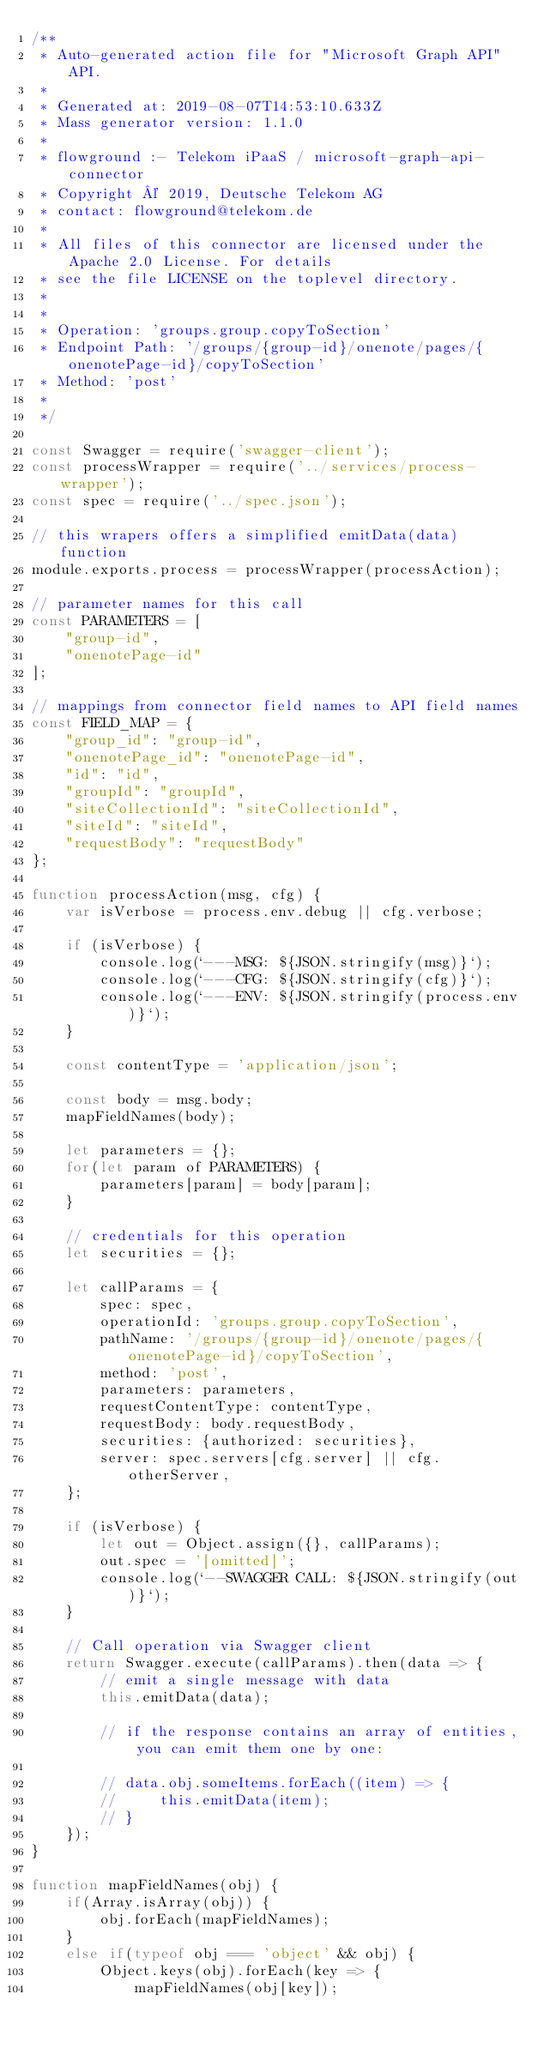Convert code to text. <code><loc_0><loc_0><loc_500><loc_500><_JavaScript_>/**
 * Auto-generated action file for "Microsoft Graph API" API.
 *
 * Generated at: 2019-08-07T14:53:10.633Z
 * Mass generator version: 1.1.0
 *
 * flowground :- Telekom iPaaS / microsoft-graph-api-connector
 * Copyright © 2019, Deutsche Telekom AG
 * contact: flowground@telekom.de
 *
 * All files of this connector are licensed under the Apache 2.0 License. For details
 * see the file LICENSE on the toplevel directory.
 *
 *
 * Operation: 'groups.group.copyToSection'
 * Endpoint Path: '/groups/{group-id}/onenote/pages/{onenotePage-id}/copyToSection'
 * Method: 'post'
 *
 */

const Swagger = require('swagger-client');
const processWrapper = require('../services/process-wrapper');
const spec = require('../spec.json');

// this wrapers offers a simplified emitData(data) function
module.exports.process = processWrapper(processAction);

// parameter names for this call
const PARAMETERS = [
    "group-id",
    "onenotePage-id"
];

// mappings from connector field names to API field names
const FIELD_MAP = {
    "group_id": "group-id",
    "onenotePage_id": "onenotePage-id",
    "id": "id",
    "groupId": "groupId",
    "siteCollectionId": "siteCollectionId",
    "siteId": "siteId",
    "requestBody": "requestBody"
};

function processAction(msg, cfg) {
    var isVerbose = process.env.debug || cfg.verbose;

    if (isVerbose) {
        console.log(`---MSG: ${JSON.stringify(msg)}`);
        console.log(`---CFG: ${JSON.stringify(cfg)}`);
        console.log(`---ENV: ${JSON.stringify(process.env)}`);
    }

    const contentType = 'application/json';

    const body = msg.body;
    mapFieldNames(body);

    let parameters = {};
    for(let param of PARAMETERS) {
        parameters[param] = body[param];
    }

    // credentials for this operation
    let securities = {};

    let callParams = {
        spec: spec,
        operationId: 'groups.group.copyToSection',
        pathName: '/groups/{group-id}/onenote/pages/{onenotePage-id}/copyToSection',
        method: 'post',
        parameters: parameters,
        requestContentType: contentType,
        requestBody: body.requestBody,
        securities: {authorized: securities},
        server: spec.servers[cfg.server] || cfg.otherServer,
    };

    if (isVerbose) {
        let out = Object.assign({}, callParams);
        out.spec = '[omitted]';
        console.log(`--SWAGGER CALL: ${JSON.stringify(out)}`);
    }

    // Call operation via Swagger client
    return Swagger.execute(callParams).then(data => {
        // emit a single message with data
        this.emitData(data);

        // if the response contains an array of entities, you can emit them one by one:

        // data.obj.someItems.forEach((item) => {
        //     this.emitData(item);
        // }
    });
}

function mapFieldNames(obj) {
    if(Array.isArray(obj)) {
        obj.forEach(mapFieldNames);
    }
    else if(typeof obj === 'object' && obj) {
        Object.keys(obj).forEach(key => {
            mapFieldNames(obj[key]);
</code> 